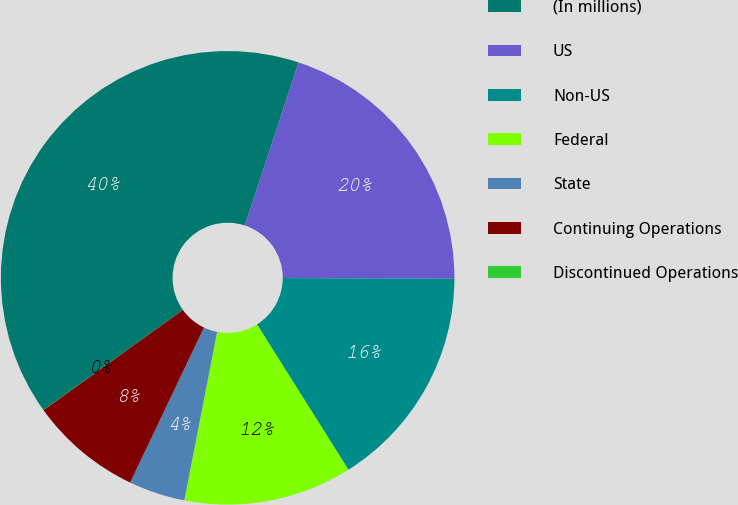Convert chart to OTSL. <chart><loc_0><loc_0><loc_500><loc_500><pie_chart><fcel>(In millions)<fcel>US<fcel>Non-US<fcel>Federal<fcel>State<fcel>Continuing Operations<fcel>Discontinued Operations<nl><fcel>39.98%<fcel>20.0%<fcel>16.0%<fcel>12.0%<fcel>4.01%<fcel>8.01%<fcel>0.01%<nl></chart> 